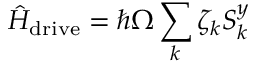Convert formula to latex. <formula><loc_0><loc_0><loc_500><loc_500>\hat { H } _ { d r i v e } = \hbar { \Omega } \sum _ { k } \zeta _ { k } S _ { k } ^ { y }</formula> 